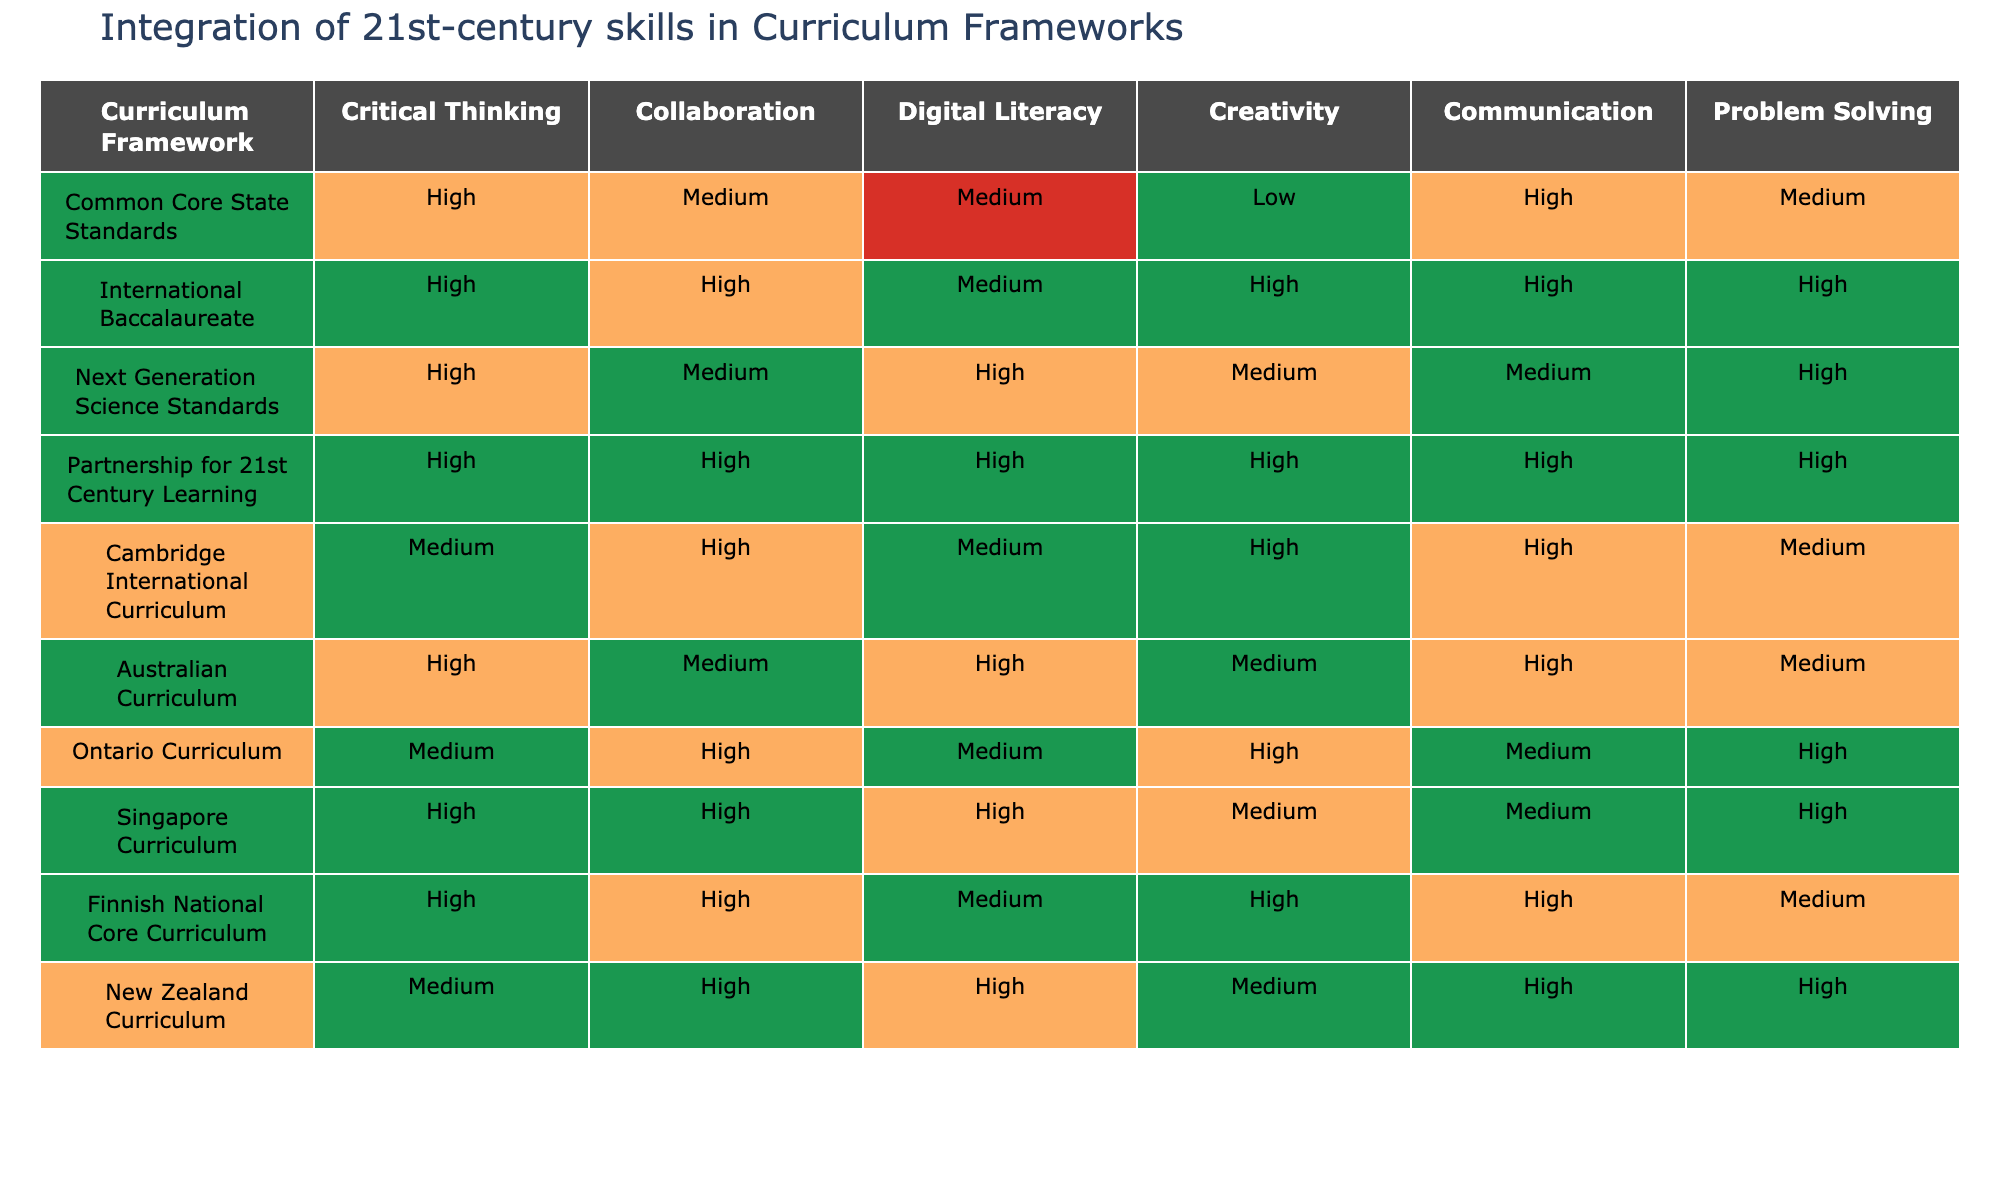What is the integration level of Creativity in the Partnership for 21st Century Learning framework? The table indicates that the integration level of Creativity in the Partnership for 21st Century Learning framework is High.
Answer: High Which curriculum frameworks have a Medium level of Digital Literacy? By inspecting the table, it can be seen that the Common Core State Standards, Cambridge International Curriculum, and Ontario Curriculum all have a Medium level of Digital Literacy.
Answer: Common Core State Standards, Cambridge International Curriculum, Ontario Curriculum Which curriculum framework has the highest level of Collaboration? The table shows that the Partnership for 21st Century Learning, International Baccalaureate, and New Zealand Curriculum all have a High level of Collaboration, making them the top frameworks for this skill.
Answer: Partnership for 21st Century Learning, International Baccalaureate, New Zealand Curriculum Is there a curriculum framework with a Low level of Critical Thinking? After reviewing the table, it is clear that no framework has a Low level for Critical Thinking; all frameworks have at least a Medium or High level for this skill.
Answer: No What is the difference in integration levels of Problem Solving between the International Baccalaureate and the Australian Curriculum? The International Baccalaureate has a High level of Problem Solving while the Australian Curriculum has a Medium level. The difference is therefore one level.
Answer: 1 level Which curriculum framework has the overall highest integration across all skills? Evaluating the table shows that the Partnership for 21st Century Learning framework has a High integration for all listed skills, indicating it is the most comprehensive.
Answer: Partnership for 21st Century Learning What is the average level of Communication across all curriculum frameworks listed? To find the average level of Communication, each framework's level can be assigned numerical values (High=2, Medium=1, Low=0). Counting yields a sum of 10 and dividing by 10 frameworks gives an average of 1.0, which corresponds to Medium.
Answer: Medium Are there any curriculum frameworks with both High Collaboration and High Creativity? Checking the table reveals that both the International Baccalaureate and the Partnership for 21st Century Learning frameworks have High levels in both Collaboration and Creativity.
Answer: Yes Which curriculum framework has the highest level of Digital Literacy among those listed? Looking at the table, the Next Generation Science Standards has a High level of Digital Literacy, which is the highest among the frameworks.
Answer: Next Generation Science Standards How many frameworks have a Low level of Creativity? The table indicates that there is only one framework, the Common Core State Standards, with a Low level of Creativity.
Answer: 1 framework 